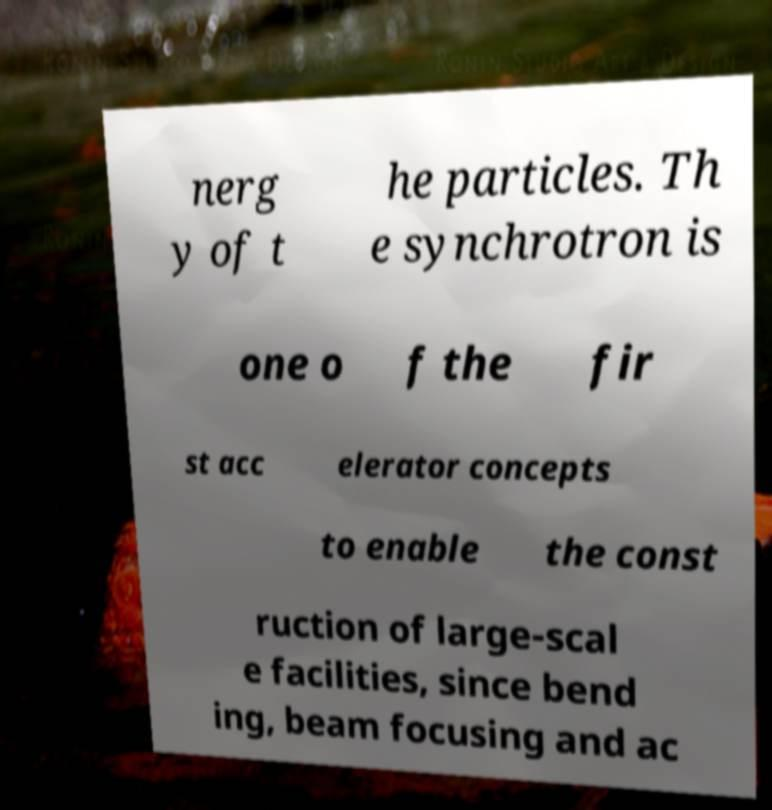Please read and relay the text visible in this image. What does it say? nerg y of t he particles. Th e synchrotron is one o f the fir st acc elerator concepts to enable the const ruction of large-scal e facilities, since bend ing, beam focusing and ac 